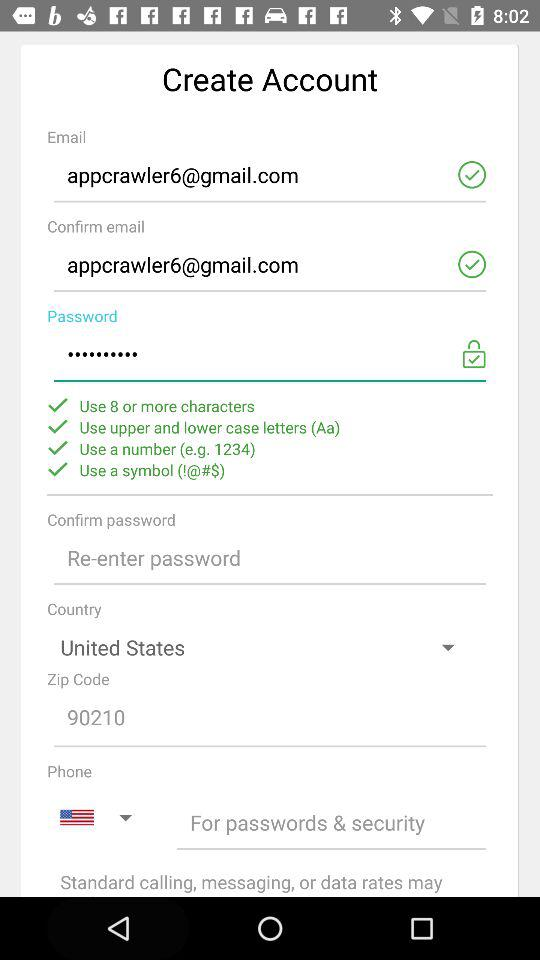How many items are required to create an account?
Answer the question using a single word or phrase. 7 